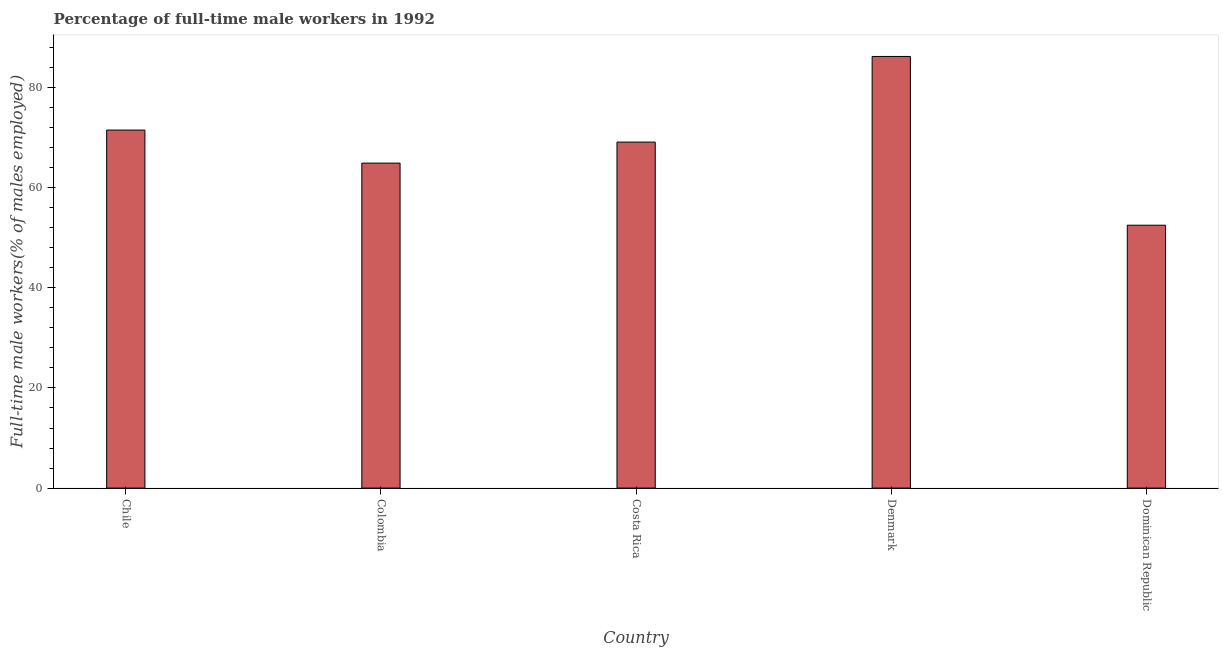What is the title of the graph?
Give a very brief answer. Percentage of full-time male workers in 1992. What is the label or title of the X-axis?
Provide a succinct answer. Country. What is the label or title of the Y-axis?
Ensure brevity in your answer.  Full-time male workers(% of males employed). What is the percentage of full-time male workers in Costa Rica?
Offer a terse response. 69.1. Across all countries, what is the maximum percentage of full-time male workers?
Your answer should be compact. 86.2. Across all countries, what is the minimum percentage of full-time male workers?
Make the answer very short. 52.5. In which country was the percentage of full-time male workers minimum?
Your response must be concise. Dominican Republic. What is the sum of the percentage of full-time male workers?
Your answer should be very brief. 344.2. What is the difference between the percentage of full-time male workers in Costa Rica and Denmark?
Give a very brief answer. -17.1. What is the average percentage of full-time male workers per country?
Ensure brevity in your answer.  68.84. What is the median percentage of full-time male workers?
Your answer should be compact. 69.1. In how many countries, is the percentage of full-time male workers greater than 12 %?
Make the answer very short. 5. What is the ratio of the percentage of full-time male workers in Costa Rica to that in Dominican Republic?
Provide a succinct answer. 1.32. Is the difference between the percentage of full-time male workers in Chile and Colombia greater than the difference between any two countries?
Your response must be concise. No. Is the sum of the percentage of full-time male workers in Chile and Dominican Republic greater than the maximum percentage of full-time male workers across all countries?
Ensure brevity in your answer.  Yes. What is the difference between the highest and the lowest percentage of full-time male workers?
Ensure brevity in your answer.  33.7. Are all the bars in the graph horizontal?
Your response must be concise. No. What is the difference between two consecutive major ticks on the Y-axis?
Ensure brevity in your answer.  20. Are the values on the major ticks of Y-axis written in scientific E-notation?
Give a very brief answer. No. What is the Full-time male workers(% of males employed) of Chile?
Offer a very short reply. 71.5. What is the Full-time male workers(% of males employed) in Colombia?
Offer a very short reply. 64.9. What is the Full-time male workers(% of males employed) in Costa Rica?
Provide a succinct answer. 69.1. What is the Full-time male workers(% of males employed) of Denmark?
Give a very brief answer. 86.2. What is the Full-time male workers(% of males employed) in Dominican Republic?
Give a very brief answer. 52.5. What is the difference between the Full-time male workers(% of males employed) in Chile and Colombia?
Offer a terse response. 6.6. What is the difference between the Full-time male workers(% of males employed) in Chile and Costa Rica?
Offer a very short reply. 2.4. What is the difference between the Full-time male workers(% of males employed) in Chile and Denmark?
Provide a short and direct response. -14.7. What is the difference between the Full-time male workers(% of males employed) in Chile and Dominican Republic?
Your answer should be compact. 19. What is the difference between the Full-time male workers(% of males employed) in Colombia and Costa Rica?
Your response must be concise. -4.2. What is the difference between the Full-time male workers(% of males employed) in Colombia and Denmark?
Your answer should be very brief. -21.3. What is the difference between the Full-time male workers(% of males employed) in Colombia and Dominican Republic?
Your answer should be very brief. 12.4. What is the difference between the Full-time male workers(% of males employed) in Costa Rica and Denmark?
Provide a short and direct response. -17.1. What is the difference between the Full-time male workers(% of males employed) in Costa Rica and Dominican Republic?
Your response must be concise. 16.6. What is the difference between the Full-time male workers(% of males employed) in Denmark and Dominican Republic?
Keep it short and to the point. 33.7. What is the ratio of the Full-time male workers(% of males employed) in Chile to that in Colombia?
Your response must be concise. 1.1. What is the ratio of the Full-time male workers(% of males employed) in Chile to that in Costa Rica?
Offer a very short reply. 1.03. What is the ratio of the Full-time male workers(% of males employed) in Chile to that in Denmark?
Give a very brief answer. 0.83. What is the ratio of the Full-time male workers(% of males employed) in Chile to that in Dominican Republic?
Provide a short and direct response. 1.36. What is the ratio of the Full-time male workers(% of males employed) in Colombia to that in Costa Rica?
Provide a succinct answer. 0.94. What is the ratio of the Full-time male workers(% of males employed) in Colombia to that in Denmark?
Keep it short and to the point. 0.75. What is the ratio of the Full-time male workers(% of males employed) in Colombia to that in Dominican Republic?
Give a very brief answer. 1.24. What is the ratio of the Full-time male workers(% of males employed) in Costa Rica to that in Denmark?
Ensure brevity in your answer.  0.8. What is the ratio of the Full-time male workers(% of males employed) in Costa Rica to that in Dominican Republic?
Your response must be concise. 1.32. What is the ratio of the Full-time male workers(% of males employed) in Denmark to that in Dominican Republic?
Ensure brevity in your answer.  1.64. 